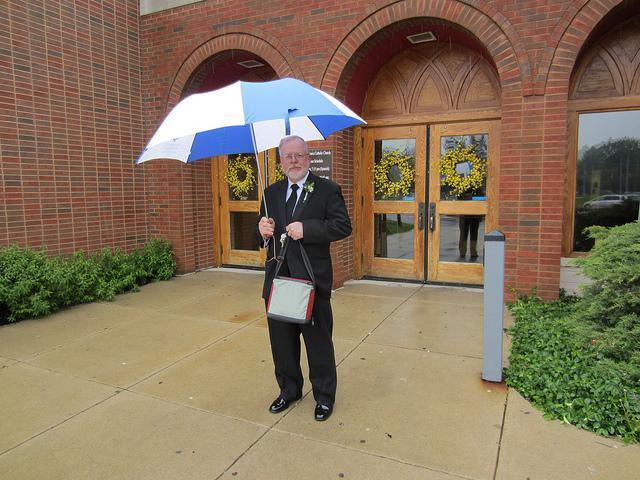How many umbrellas are visible?
Give a very brief answer. 1. 